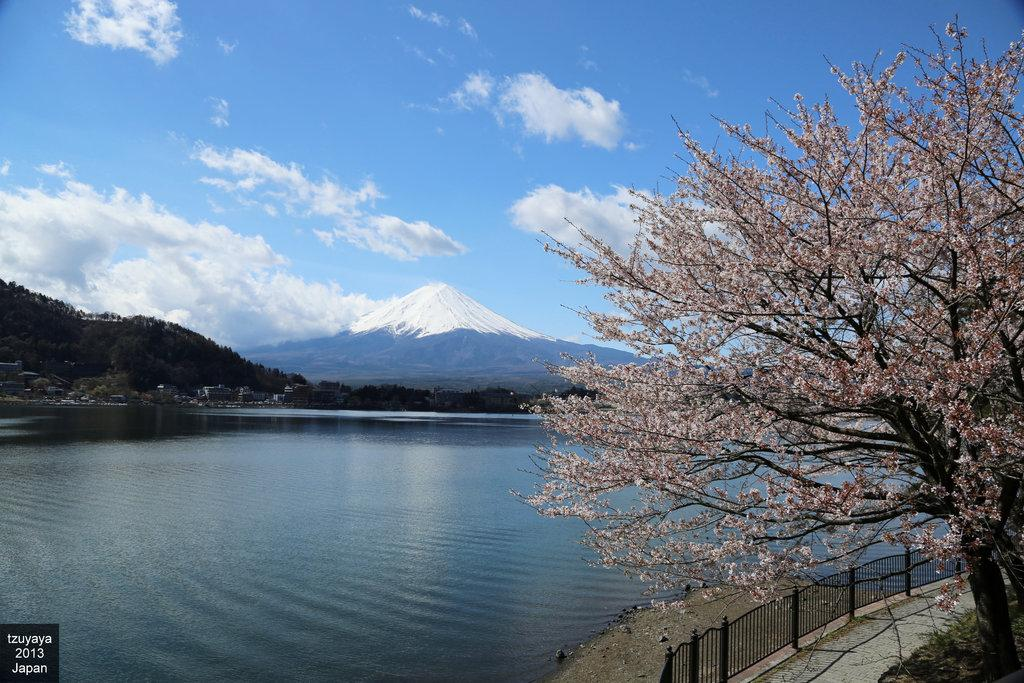What is located on the left side of the image? There is a water body on the left side of the image. What is on the right side of the image? There are trees and a boundary on the right side of the image. What can be seen in the background of the image? There are trees, hills, and buildings in the background of the image. How would you describe the sky in the image? The sky is cloudy in the image. Can you see a girl playing volleyball in the image? There is no girl playing volleyball in the image. Is there a snake visible in the water body on the left side of the image? There is no snake present in the image. 